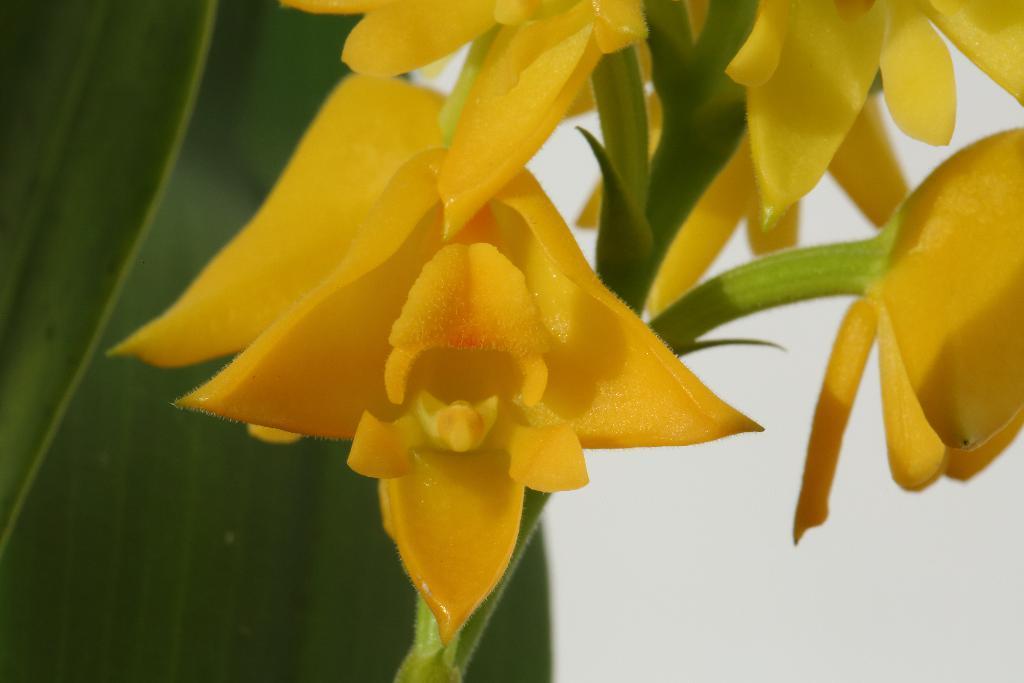In one or two sentences, can you explain what this image depicts? In the picture we can see the yellow color flowers to the stem and behind it, we can see a part of the leaf. 